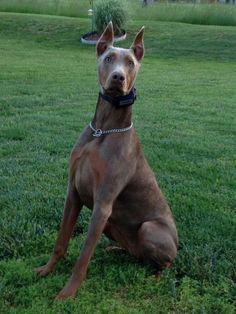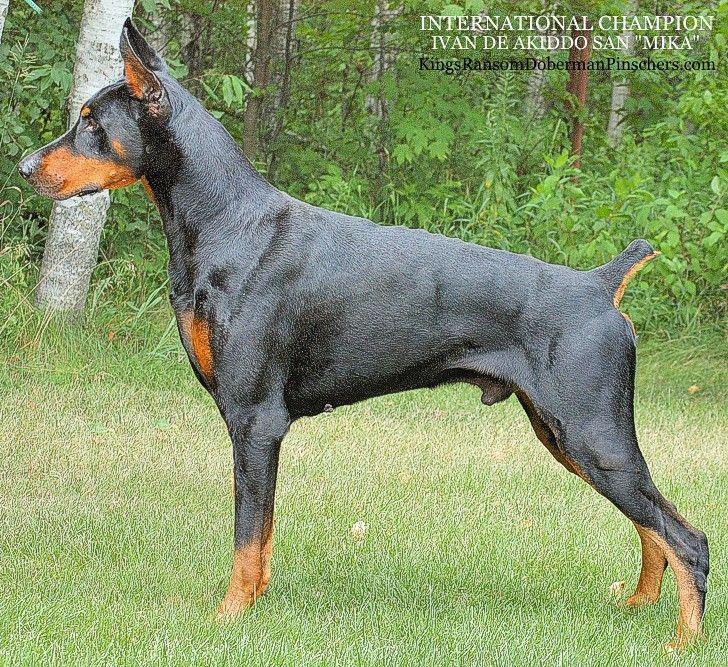The first image is the image on the left, the second image is the image on the right. Given the left and right images, does the statement "One image shows a doberman with erect ears and docked tail standing in profile facing left, and the other image shows a non-standing doberman wearing a collar." hold true? Answer yes or no. Yes. The first image is the image on the left, the second image is the image on the right. Examine the images to the left and right. Is the description "One of the dogs is standing with its head facing left." accurate? Answer yes or no. Yes. 